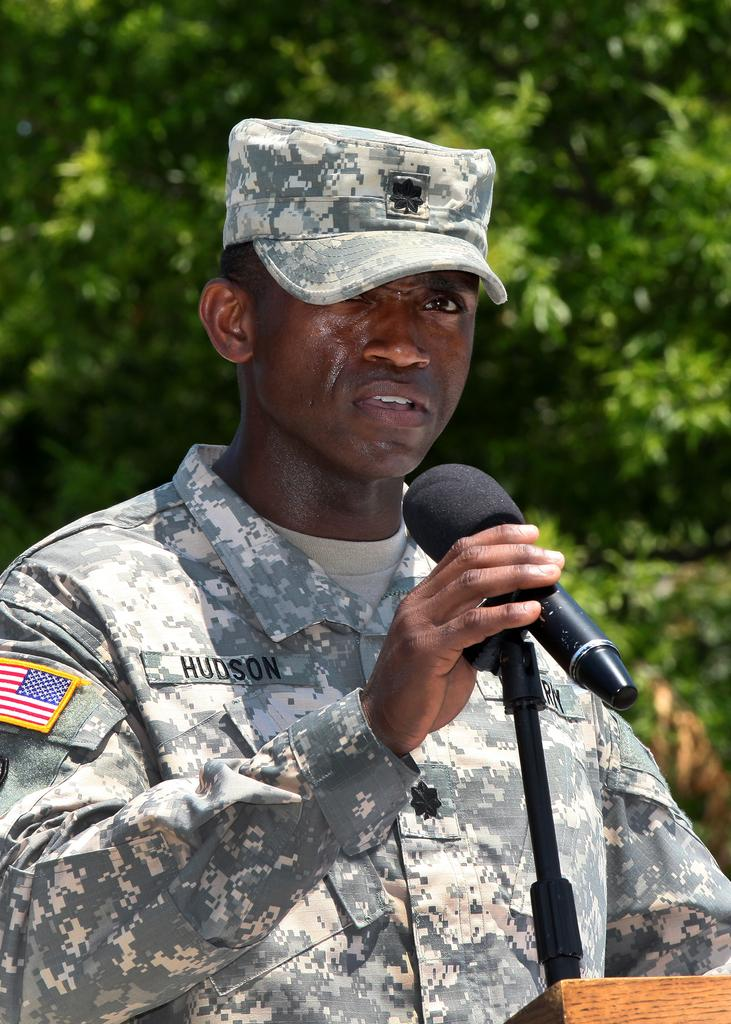Who is present in the image? There is a man in the image. What is the man doing in the image? The man is standing and holding a mic. What can be seen in the background of the image? There are trees visible in the background of the image. Can you see the coast or the seashore in the image? There is no mention of a coast or a seashore in the image. 